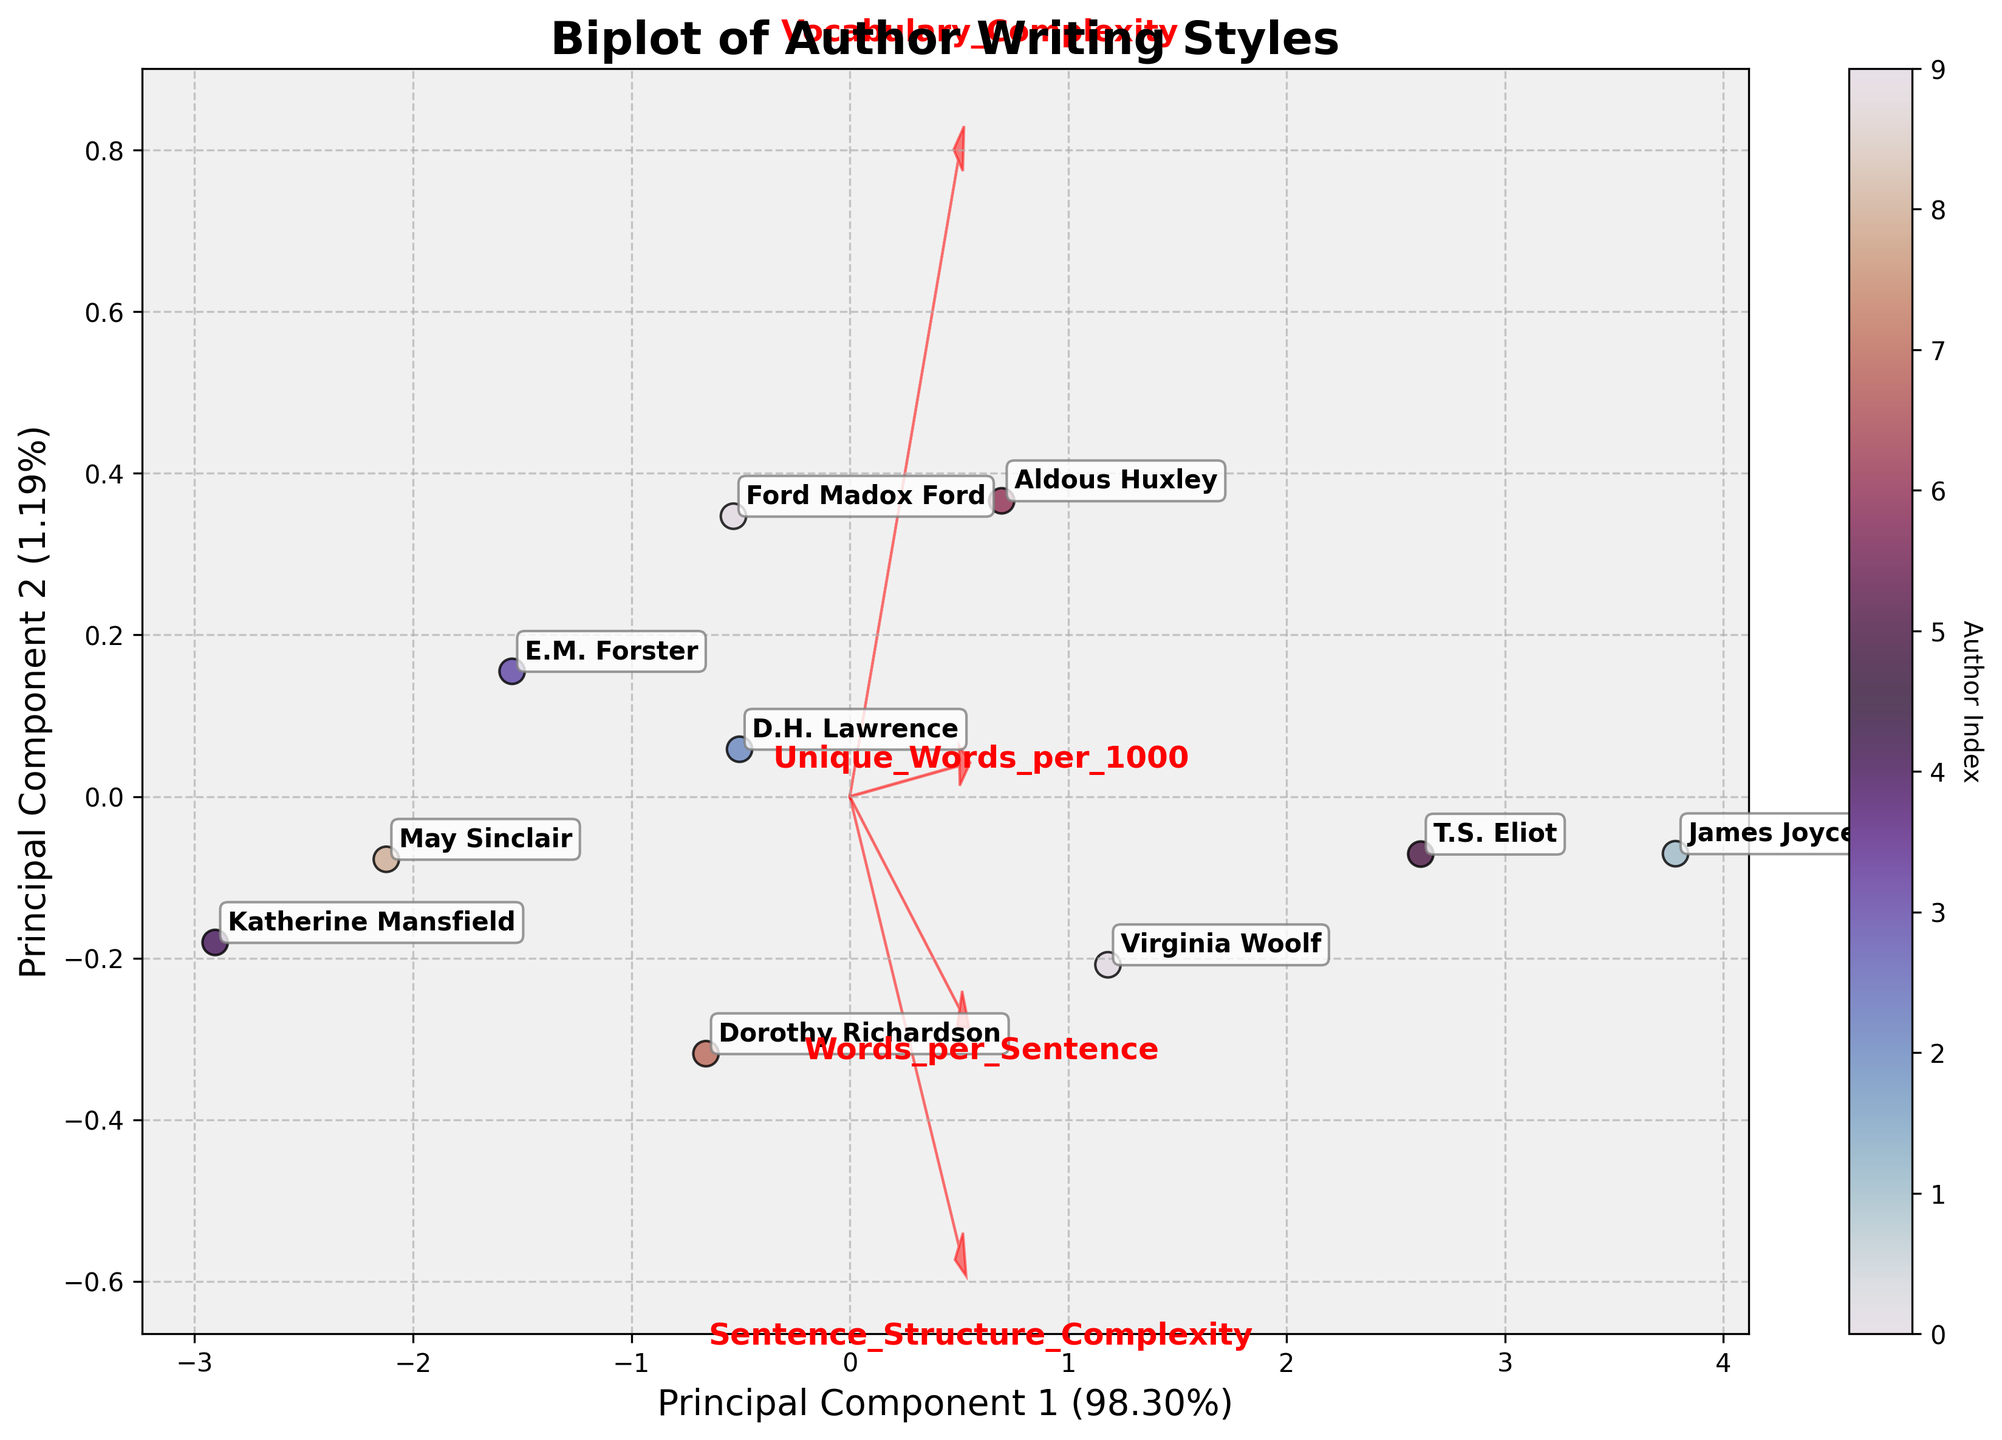Which author has the highest Vocabulary Complexity? The author with the highest Vocabulary Complexity will have the maximum value along the 'Vocabulary_Complexity' axis in the biplot. Identify the point that is farthest along the direction of the Vocabulary Complexity loadings arrow.
Answer: James Joyce Which feature contributes the most to Principal Component 1 (PC1)? The feature with the longest arrow along the Principal Component 1 axis contributes the most. Measure the projections of the feature loadings arrows on the PC1 axis.
Answer: Words_per_Sentence How many authors are displayed in the plot? Count the number of unique points or labels corresponding to different authors in the biplot.
Answer: 10 Which two authors have the most similar writing styles based on the biplot? Look for two points that are closest to each other in the biplot, indicating similar scores on the principal components.
Answer: Ford Madox Ford and Dorothy Richardson What is the total percentage of variance explained by the first two principal components? Sum the explained variance percentages of Principal Component 1 and Principal Component 2 shown in the axis labels.
Answer: (PC1 explained variance percentage + PC2 explained variance percentage) Which feature has the highest contribution toward Principal Component 2 (PC2)? The feature whose arrow has the longest projection on the Principal Component 2 axis has the highest contribution. Measure the projections of feature loadings on the PC2 axis.
Answer: Unique_Words_per_1000 Among the authors, whose writing style is most influenced by Sentence Structure Complexity? Identify the author closest to the direction of the arrow marked 'Sentence_Structure_Complexity' in the biplot. Measure how far along they are projected in that direction.
Answer: James Joyce What principal component value distinguishes T.S. Eliot's writing style? Locate T.S. Eliot's point on the plot and note its location along the PC1 and PC2 axes.
Answer: (PC1 value for T.S. Eliot, PC2 value for T.S. Eliot) How is May Sinclair's writing style positioned compared to D.H. Lawrence on both Principal Components? Compare the distances of May Sinclair and D.H. Lawrence along both PC1 and PC2 axes in the biplot.
Answer: (May Sinclair's PC1 < D.H. Lawrence's PC1, May Sinclair's PC2 ~ D.H. Lawrence's PC2) Which author is projected furthest along the Principal Component 1? Find the point with the highest absolute value along the PC1 axis.
Answer: T.S. Eliot 